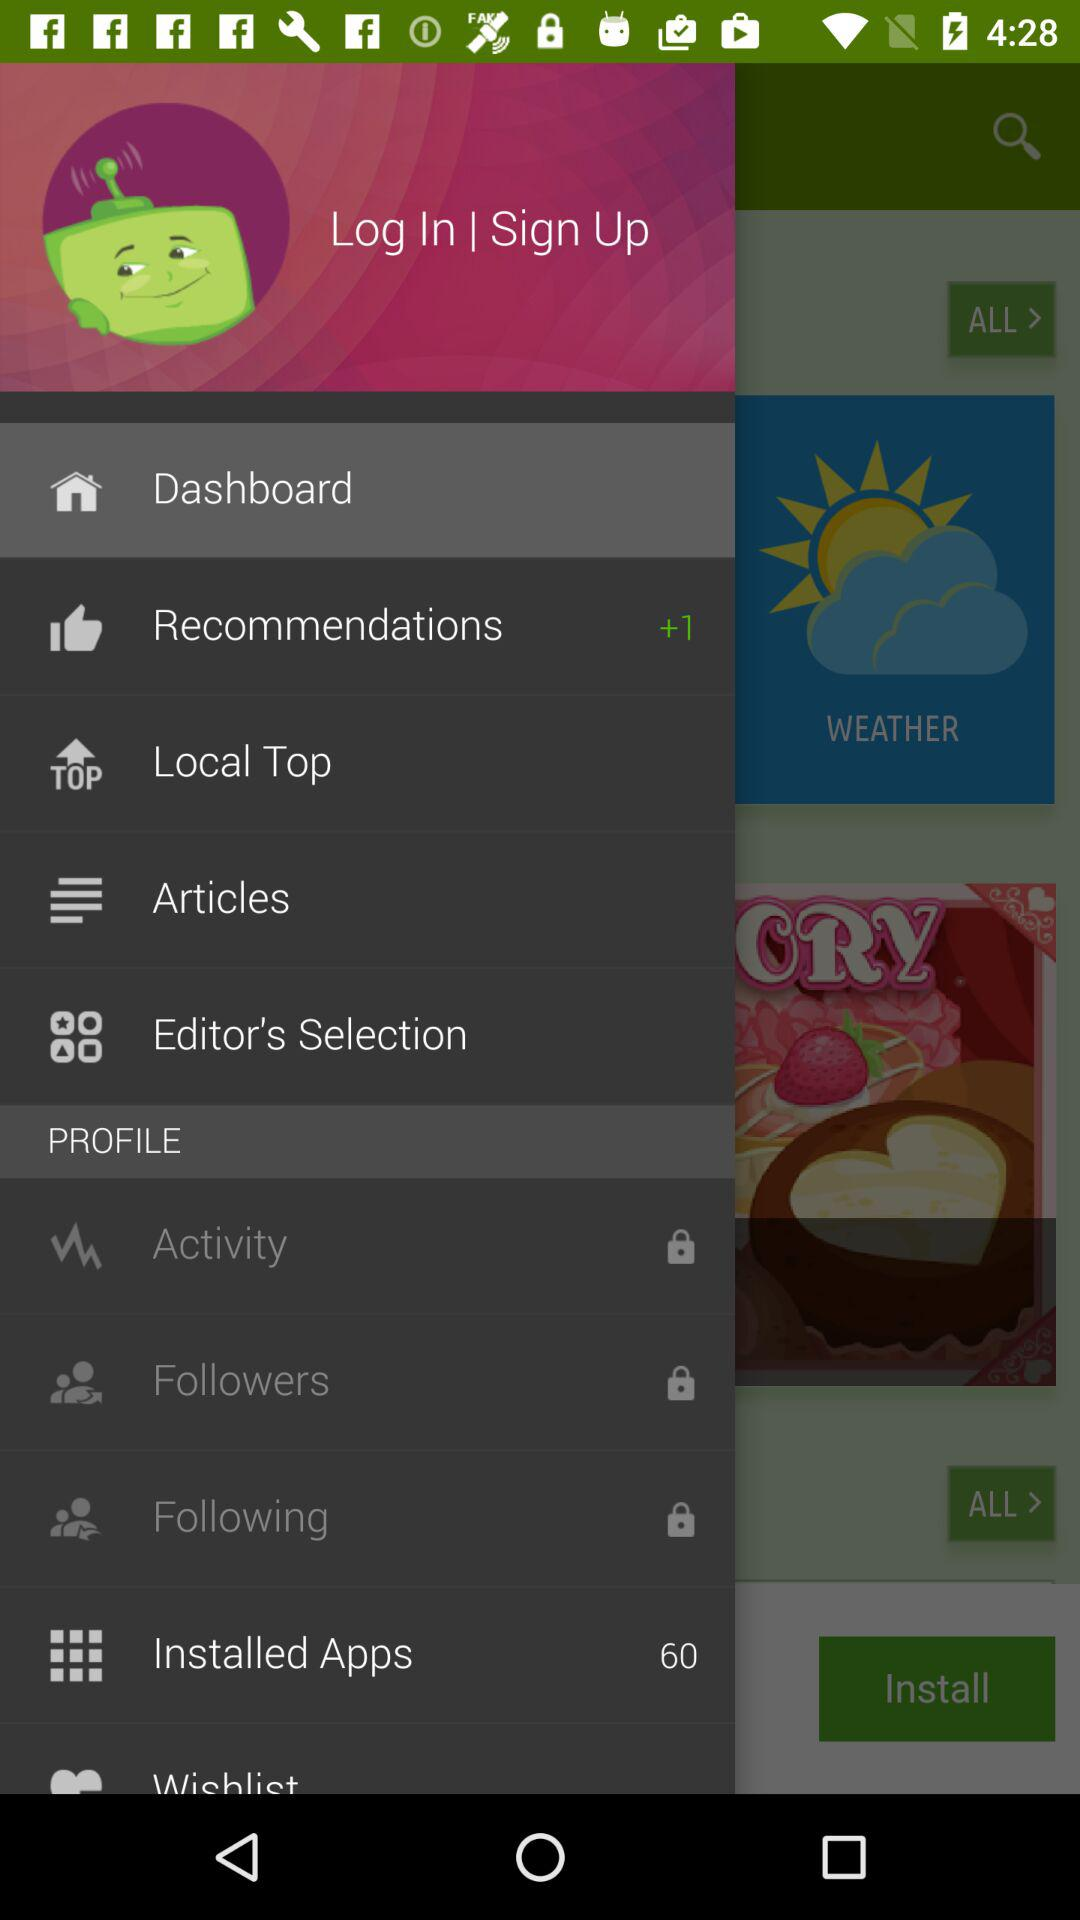Which item has been selected in the menu? The selected item in the menu is "Dashboard". 